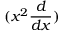<formula> <loc_0><loc_0><loc_500><loc_500>( x ^ { 2 } \frac { d } { d x } )</formula> 